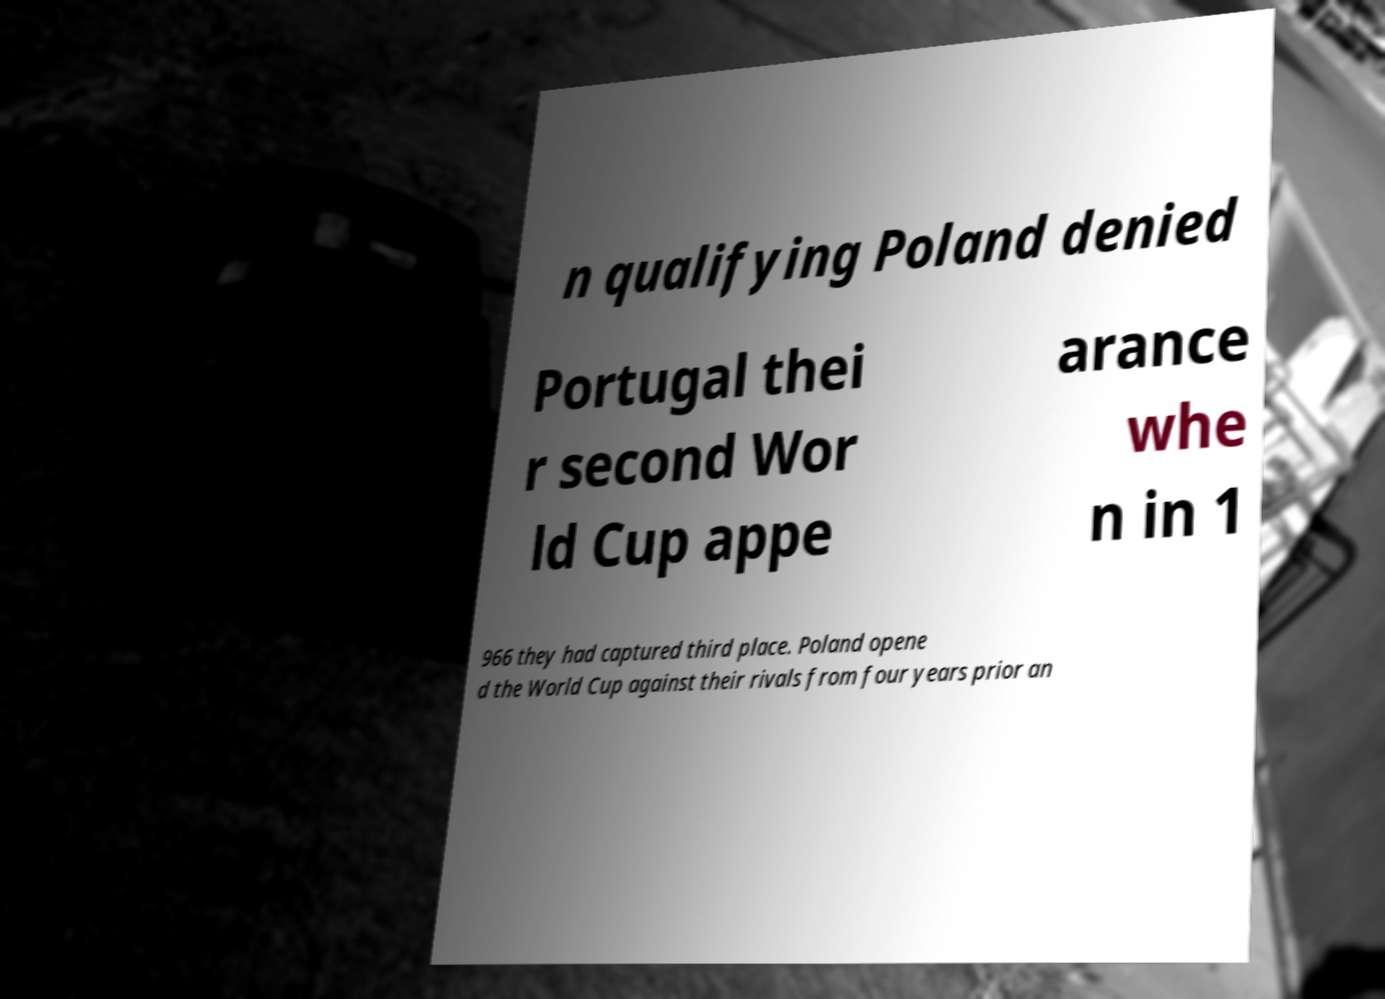Please identify and transcribe the text found in this image. n qualifying Poland denied Portugal thei r second Wor ld Cup appe arance whe n in 1 966 they had captured third place. Poland opene d the World Cup against their rivals from four years prior an 